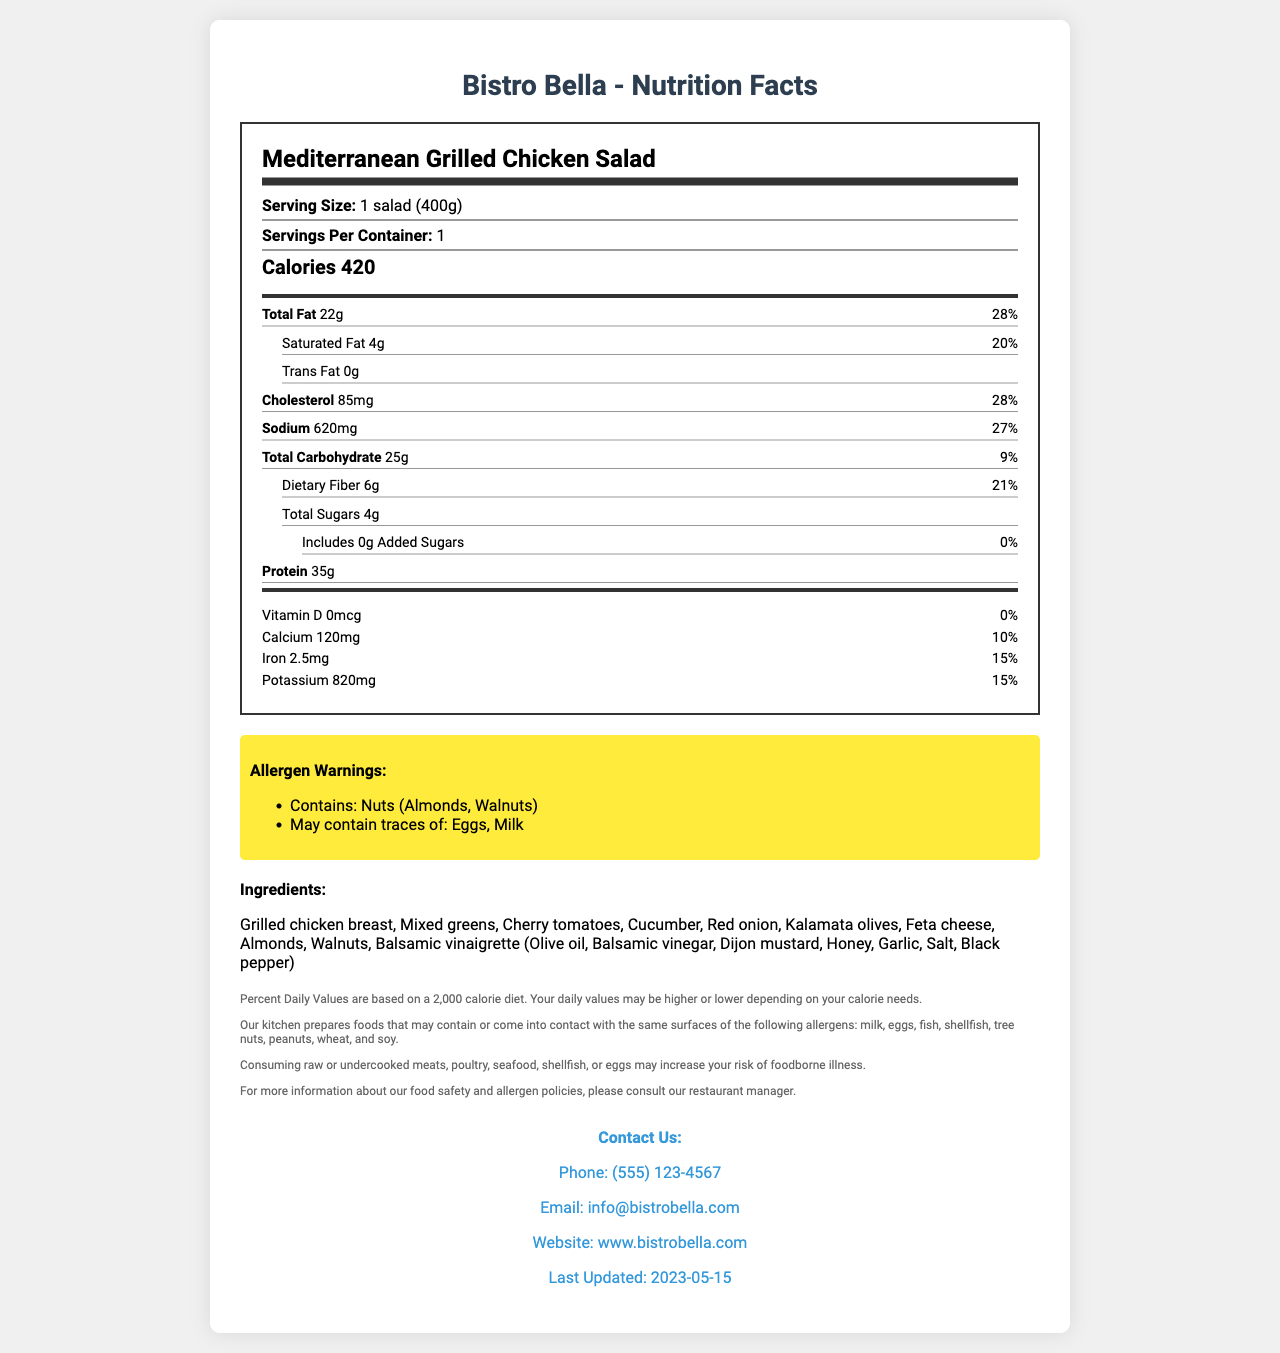how many calories are in the Mediterranean Grilled Chicken Salad? The document specifies that there are 420 calories in one serving of the Mediterranean Grilled Chicken Salad.
Answer: 420 what is the serving size for the Mediterranean Grilled Chicken Salad? The serving size is given as "1 salad (400g)" in the document.
Answer: 1 salad (400g) what are the total fat grams and their daily value percentage? The document states the total fat as 22g with a percent daily value of 28%.
Answer: 22g, 28% how much protein does the Mediterranean Grilled Chicken Salad contain? The protein content of the salad is explicitly stated as 35g.
Answer: 35g which allergens are contained in the Mediterranean Grilled Chicken Salad? The allergen warnings specify that the salad contains nuts, particularly almonds and walnuts.
Answer: Nuts (Almonds, Walnuts) how much sodium is in one salad, and what is the daily value percentage? The sodium amount is listed as 620mg with a percent daily value of 27%.
Answer: 620mg, 27% Multiple-choice: What ingredients are included in the Mediterranean Grilled Chicken Salad?
A. Grilled chicken breast, Kale, Balsamic vinaigrette
B. Grilled chicken breast, Mixed greens, Balsamic vinaigrette
C. Poached chicken breast, Mixed greens, Caesar dressing
D. Grilled chicken breast, Spinach, Ranch dressing The document lists the ingredients as Grilled chicken breast, Mixed greens, Cherry tomatoes, Cucumber, Red onion, Kalamata olives, Feta cheese, Almonds, Walnuts, Balsamic vinaigrette.
Answer: B Multiple-choice: How many grams of dietary fiber are in the salad and what percentage of daily value does it represent?
I. 4g, 21%
II. 6g, 21%
III. 6g, 20%
IV. 4g, 20% The document lists the dietary fiber as 6g, which accounts for 21% of the daily value.
Answer: II True or False: The Mediterranean Grilled Chicken Salad contains no added sugars. According to the document, the salad contains 0g of added sugars.
Answer: True summary question: Describe the key nutritional information and allergen warnings for the Mediterranean Grilled Chicken Salad. The document provides detailed nutritional information, allergen warnings, and contact details for Bistro Bella. This information includes specific measurements for fats, cholesterol, sodium, carbohydrates, sugars, protein, and essential vitamins and minerals. The allergen warnings note the presence of nuts and possible traces of eggs and milk.
Answer: The Mediterranean Grilled Chicken Salad from Bistro Bella offers 420 calories per serving (400g). It includes 22g of total fat (28% DV), 4g of saturated fat (20% DV), and 0g of trans fat. It also contains 85mg of cholesterol (28% DV), 620mg of sodium (27% DV), 25g of total carbohydrates (9% DV), 6g of dietary fiber (21% DV), and 35g of protein. Important vitamins and minerals include calcium (10% DV), iron (15% DV), and potassium (15% DV). The salad contains nuts (almonds, walnuts) and may contain traces of eggs and milk. can this salad be safely consumed by someone with a severe dairy allergy? While the allergen warnings suggest that the salad may contain traces of milk, they do not provide enough detail to determine if it can be safely consumed by someone with a severe dairy allergy. The best course of action would be to consult directly with the restaurant.
Answer: Not enough information what is the vitamin D content and its daily value percentage? The document specifies that the salad contains 0mcg of Vitamin D, which is 0% of the daily value.
Answer: 0mcg, 0% how many grams of total sugars are included in the salad? The total sugars in the salad are listed as 4g.
Answer: 4g 